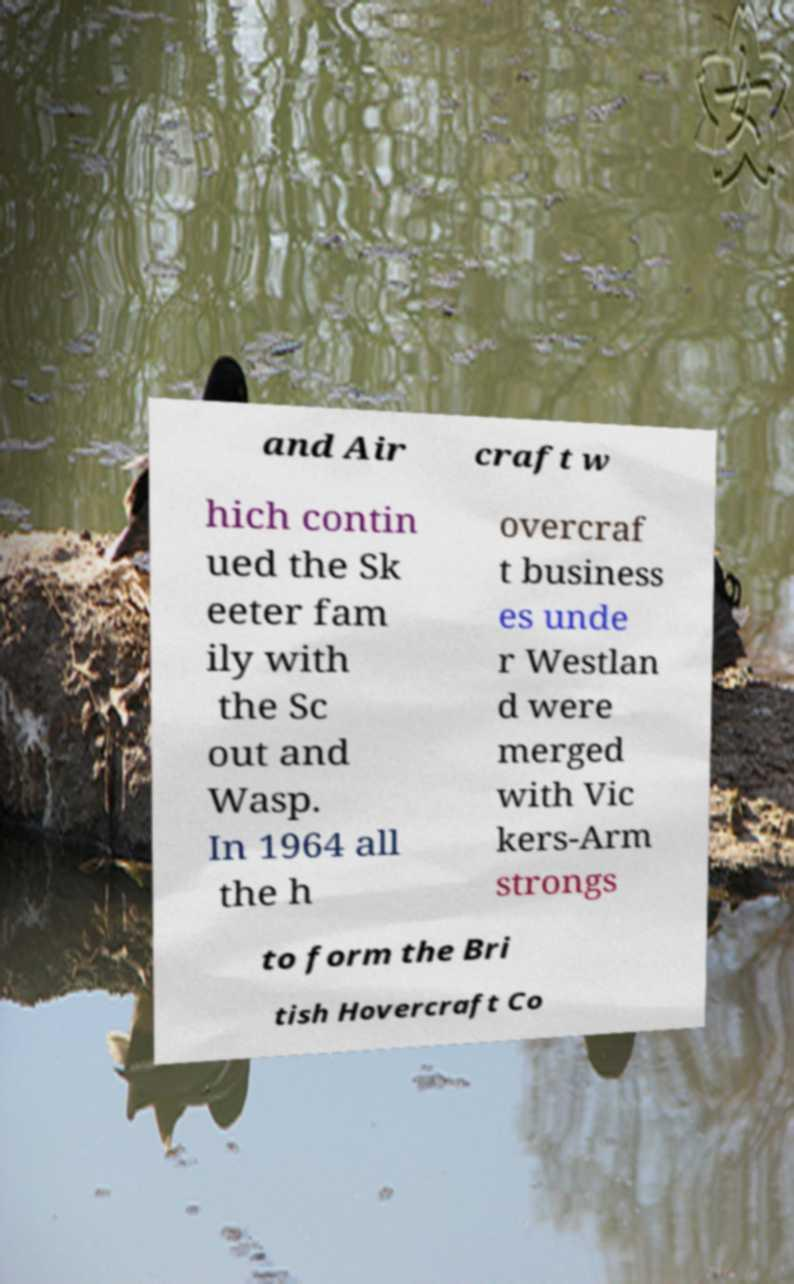Please identify and transcribe the text found in this image. and Air craft w hich contin ued the Sk eeter fam ily with the Sc out and Wasp. In 1964 all the h overcraf t business es unde r Westlan d were merged with Vic kers-Arm strongs to form the Bri tish Hovercraft Co 